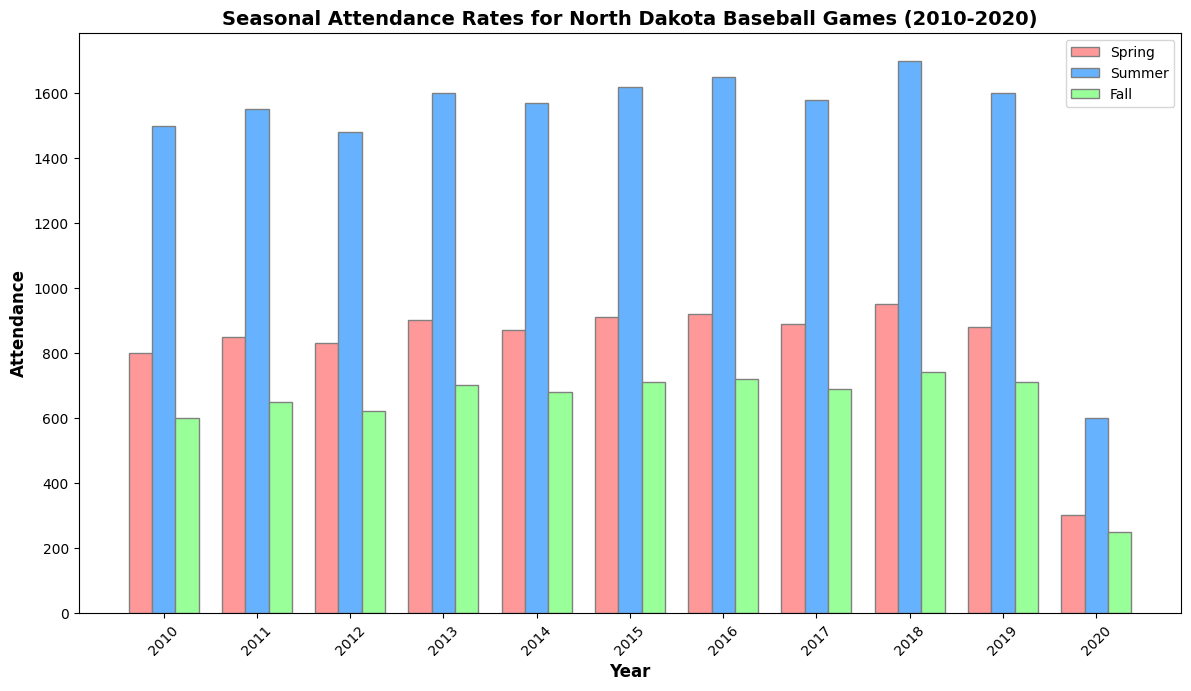What's the attendance difference between Spring and Summer in 2020? To find the difference in attendance between Spring and Summer in 2020, refer to the heights of the red and blue bars for 2020. The Spring attendance is 300 and the Summer attendance is 600. Subtracting these gives 600 - 300 = 300
Answer: 300 Which year had the highest attendance in Fall? Look at the green bars for each year and find the tallest one, which represents the highest attendance. The tallest green bar is in 2018 with an attendance of 740.
Answer: 2018 What is the average Spring attendance from 2010 to 2020? Add up all the Spring attendance values from each year and divide by the number of years (11 in total). Sum: 800 + 850 + 830 + 900 + 870 + 910 + 920 + 890 + 950 + 880 + 300 = 9100. Average = 9100 / 11 = 827.27
Answer: 827.27 In which year was the summer attendance equal to or greater than the spring and fall attendances combined? For each year, add the Spring and Fall attendances and see if the Summer attendance is greater than or equal to this sum. For 2011, Summer attendance (1550) is equal to Spring (850) + Fall (650) = 1500.
Answer: 2011 Which season had the most consistent attendance over the years? Look at the bars' heights for each season (red = Spring, blue = Summer, green = Fall) over the years. Summer has the most consistent attendance with relatively small variations in bar heights compared to Spring and Fall.
Answer: Summer What is the total attendance for all seasons combined in 2015? Sum the attendances for Spring, Summer, and Fall in 2015. Spring = 910, Summer = 1620, Fall = 710. Total = 910 + 1620 + 710 = 3240.
Answer: 3240 What is the trend of Fall attendance from 2010 to 2020? Observe the green bars over the years from 2010 to 2020. The attendance increases from 2010 to 2018, then drops significantly in 2020.
Answer: Generally increasing, then a sharp drop in 2020 